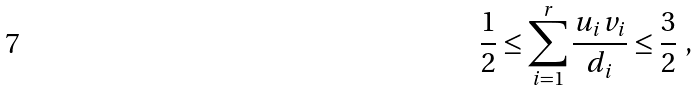<formula> <loc_0><loc_0><loc_500><loc_500>\frac { 1 } { 2 } \leq \sum _ { i = 1 } ^ { r } \frac { u _ { i } v _ { i } } { d _ { i } } \leq \frac { 3 } { 2 } \ ,</formula> 